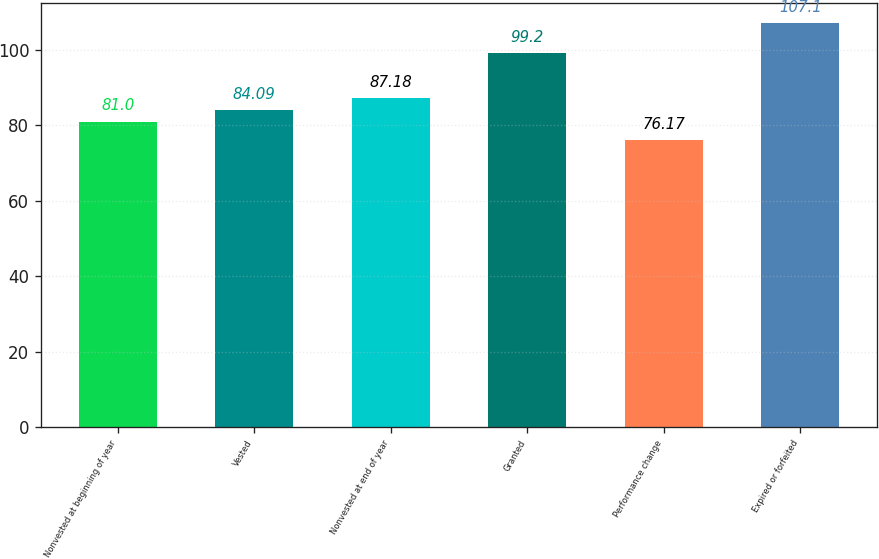<chart> <loc_0><loc_0><loc_500><loc_500><bar_chart><fcel>Nonvested at beginning of year<fcel>Vested<fcel>Nonvested at end of year<fcel>Granted<fcel>Performance change<fcel>Expired or forfeited<nl><fcel>81<fcel>84.09<fcel>87.18<fcel>99.2<fcel>76.17<fcel>107.1<nl></chart> 